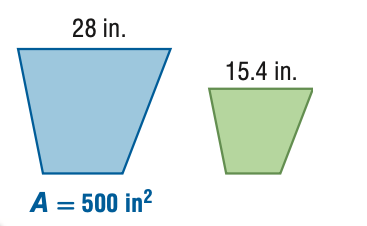Answer the mathemtical geometry problem and directly provide the correct option letter.
Question: For the pair of similar figures, find the area of the green figure.
Choices: A: 151.25 B: 275.00 C: 909.09 D: 1652.89 A 